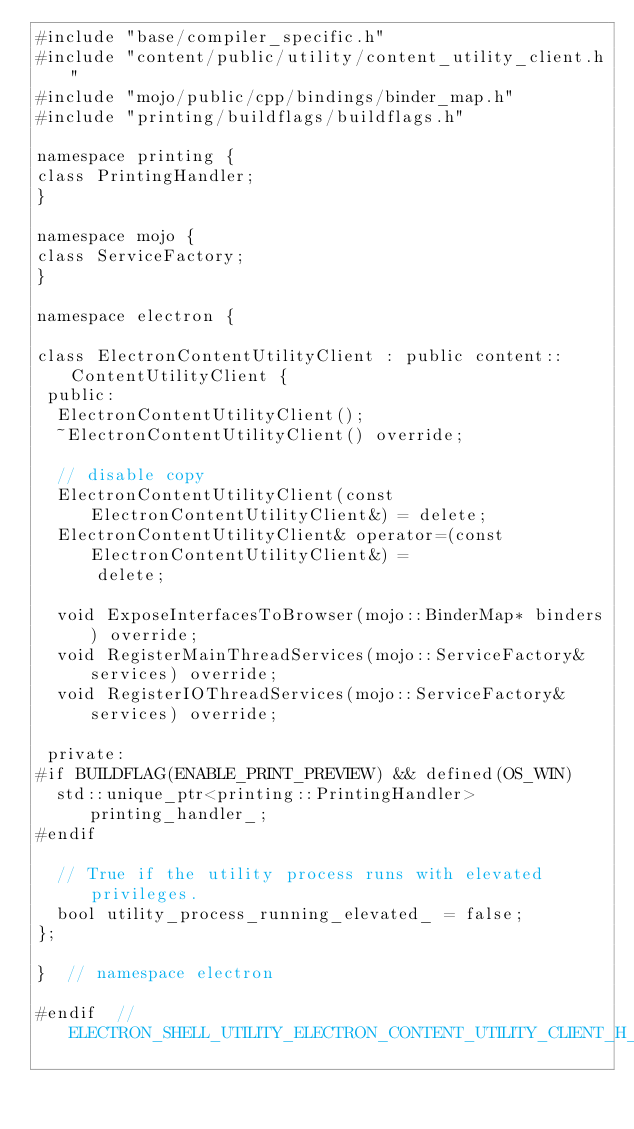<code> <loc_0><loc_0><loc_500><loc_500><_C_>#include "base/compiler_specific.h"
#include "content/public/utility/content_utility_client.h"
#include "mojo/public/cpp/bindings/binder_map.h"
#include "printing/buildflags/buildflags.h"

namespace printing {
class PrintingHandler;
}

namespace mojo {
class ServiceFactory;
}

namespace electron {

class ElectronContentUtilityClient : public content::ContentUtilityClient {
 public:
  ElectronContentUtilityClient();
  ~ElectronContentUtilityClient() override;

  // disable copy
  ElectronContentUtilityClient(const ElectronContentUtilityClient&) = delete;
  ElectronContentUtilityClient& operator=(const ElectronContentUtilityClient&) =
      delete;

  void ExposeInterfacesToBrowser(mojo::BinderMap* binders) override;
  void RegisterMainThreadServices(mojo::ServiceFactory& services) override;
  void RegisterIOThreadServices(mojo::ServiceFactory& services) override;

 private:
#if BUILDFLAG(ENABLE_PRINT_PREVIEW) && defined(OS_WIN)
  std::unique_ptr<printing::PrintingHandler> printing_handler_;
#endif

  // True if the utility process runs with elevated privileges.
  bool utility_process_running_elevated_ = false;
};

}  // namespace electron

#endif  // ELECTRON_SHELL_UTILITY_ELECTRON_CONTENT_UTILITY_CLIENT_H_
</code> 